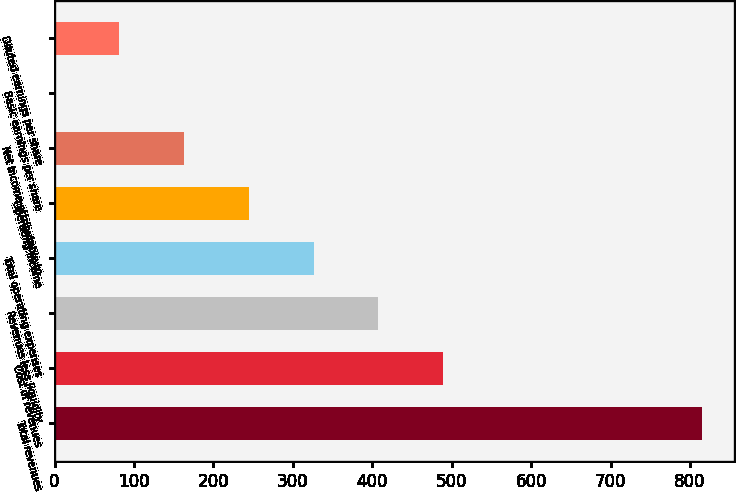Convert chart. <chart><loc_0><loc_0><loc_500><loc_500><bar_chart><fcel>Total revenues<fcel>Cost of revenues<fcel>Revenues less liquidity<fcel>Total operating expenses<fcel>Operating income<fcel>Net income attributable to<fcel>Basic earnings per share<fcel>Diluted earnings per share<nl><fcel>815<fcel>489.08<fcel>407.6<fcel>326.12<fcel>244.64<fcel>163.16<fcel>0.2<fcel>81.68<nl></chart> 